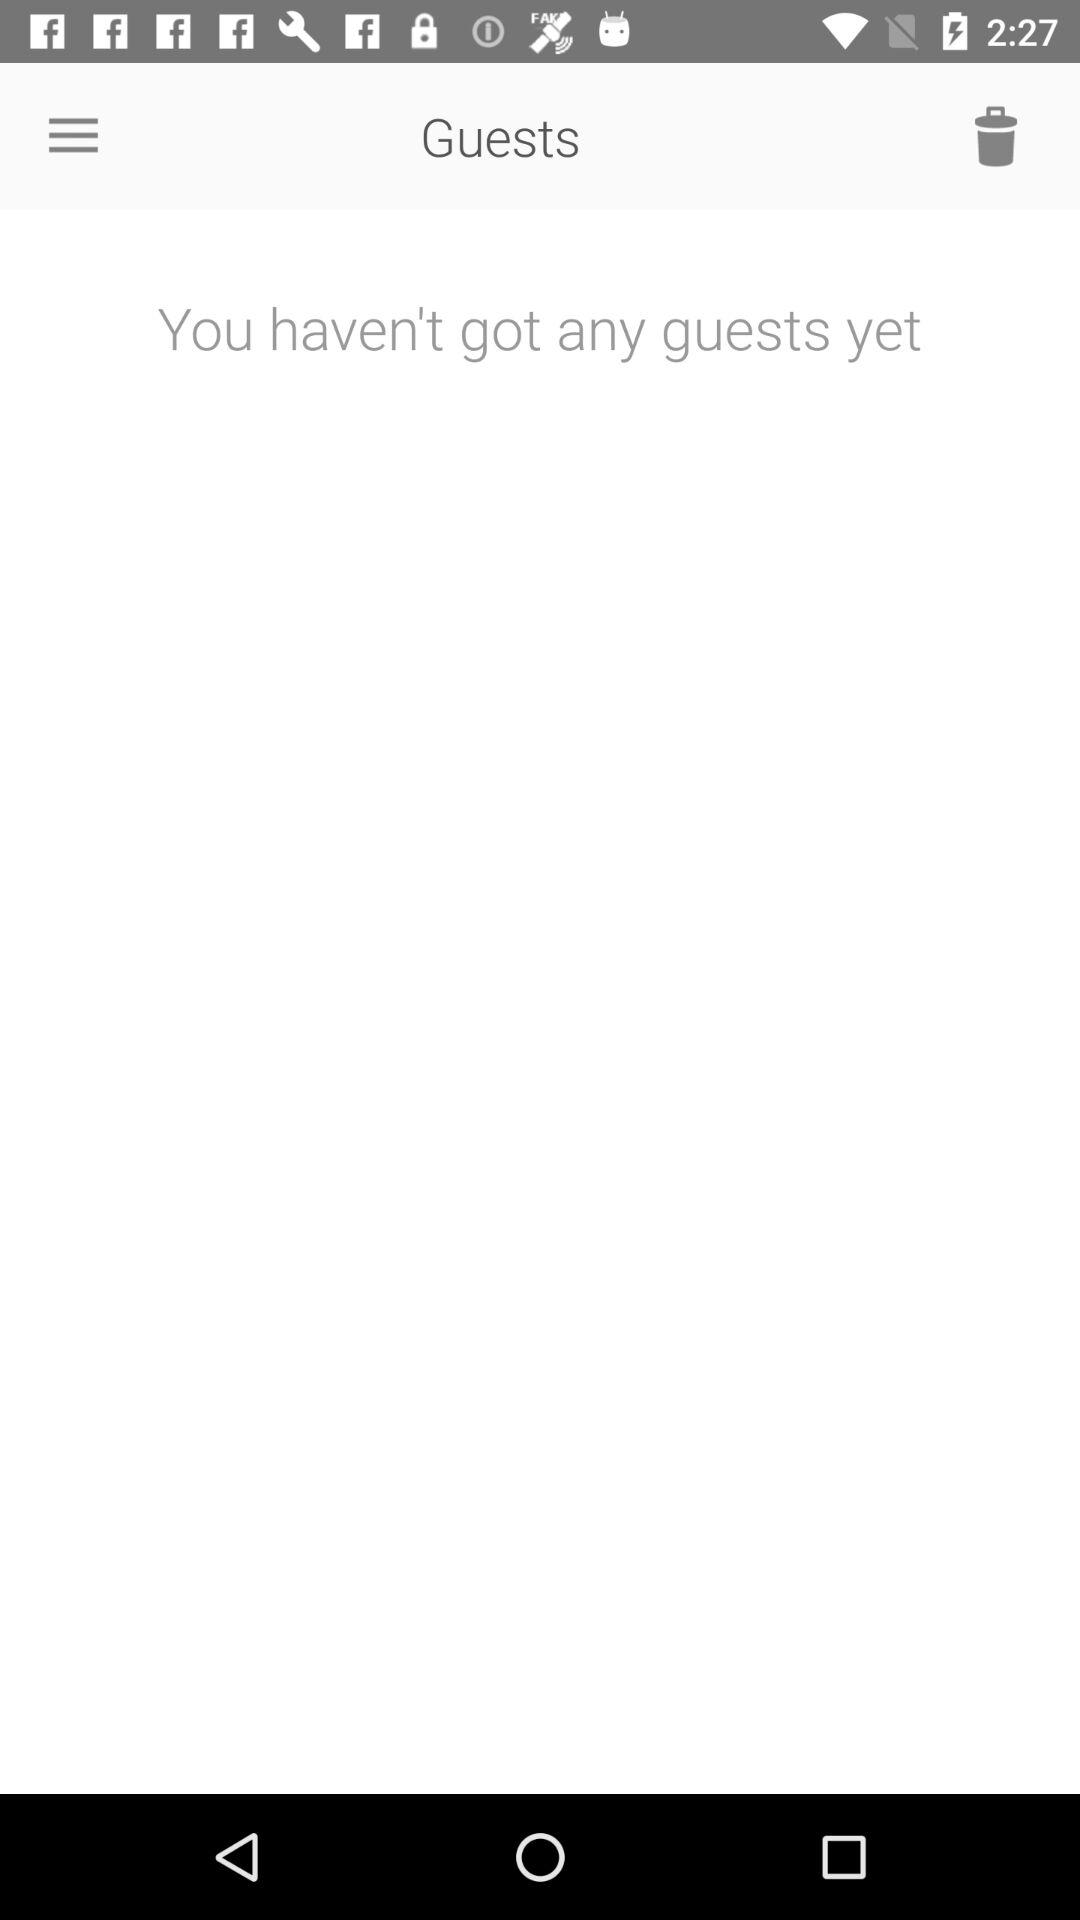What is the application name?
When the provided information is insufficient, respond with <no answer>. <no answer> 